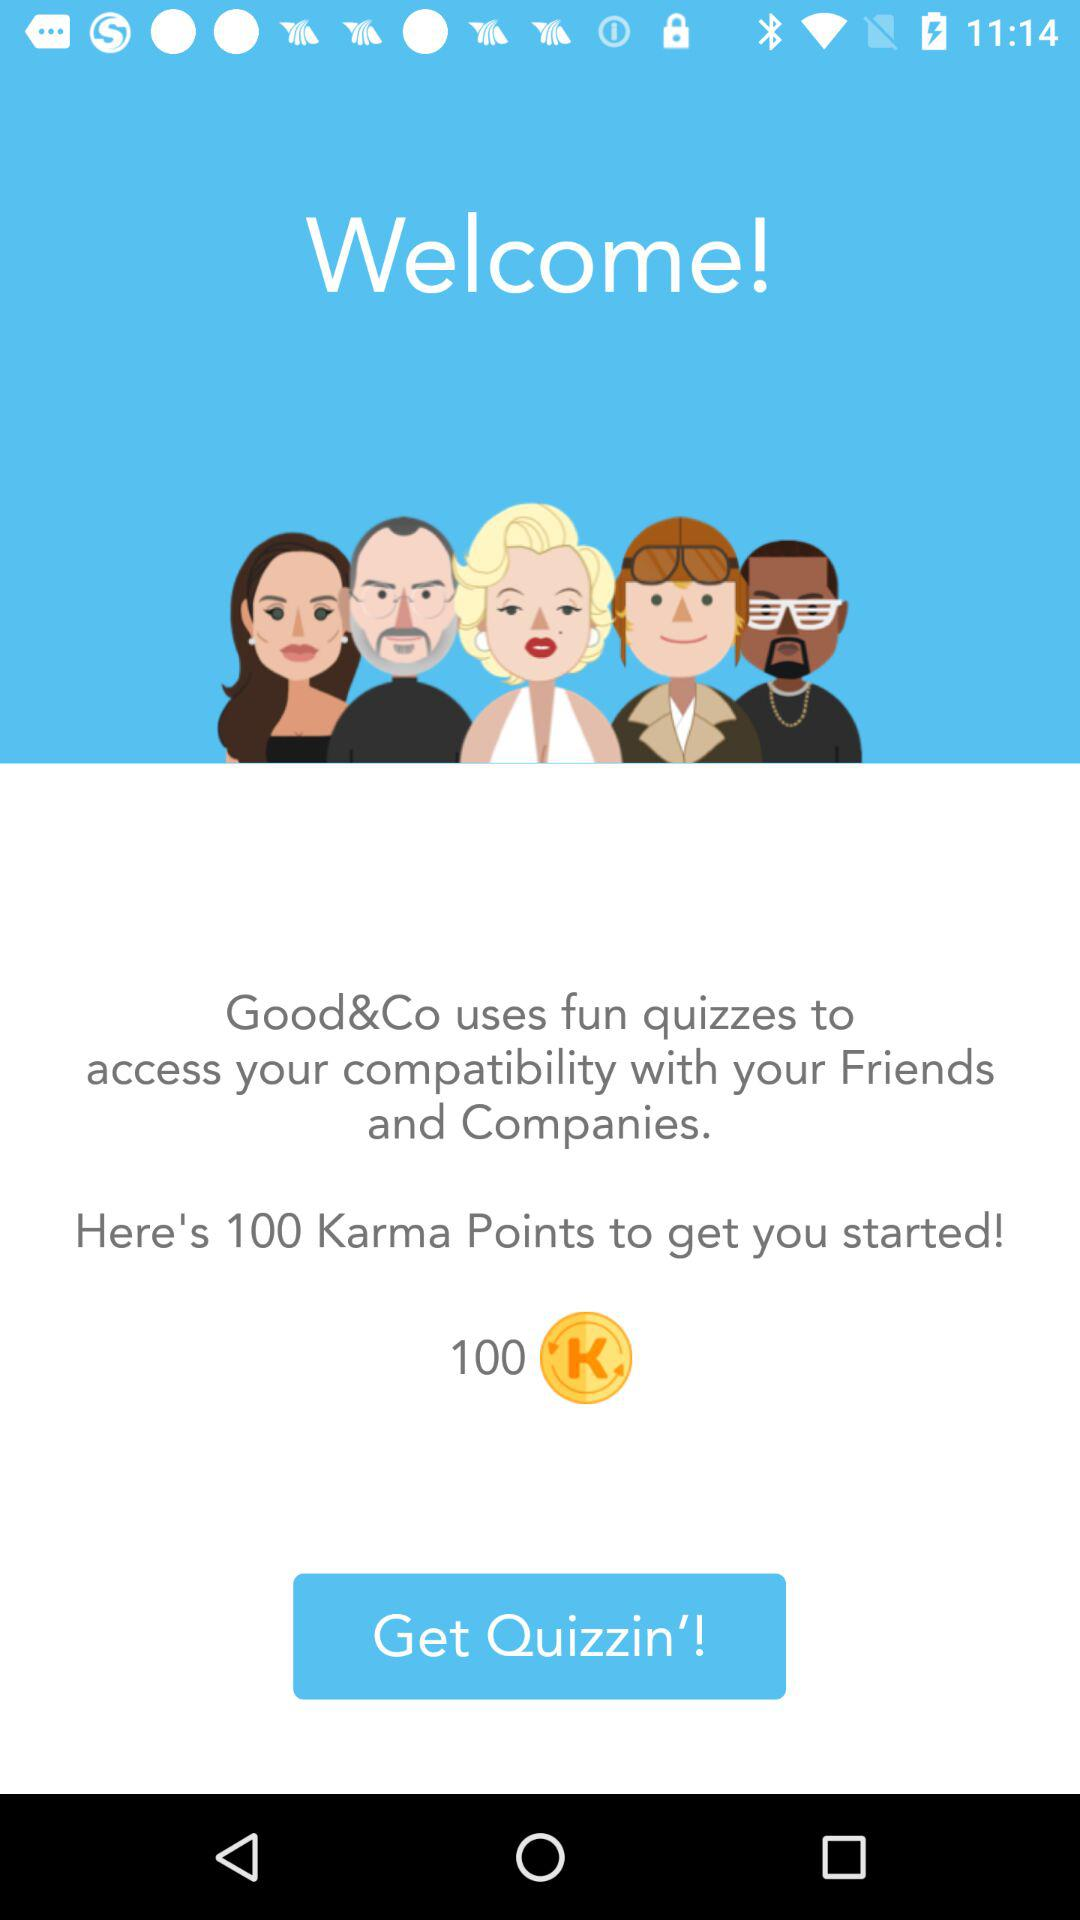How many Karma Points are there to get started? There are 100 Karma Points. 